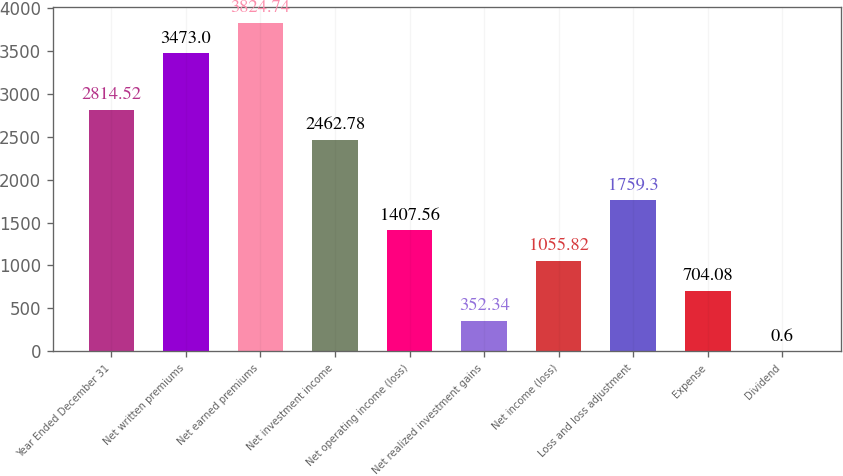Convert chart to OTSL. <chart><loc_0><loc_0><loc_500><loc_500><bar_chart><fcel>Year Ended December 31<fcel>Net written premiums<fcel>Net earned premiums<fcel>Net investment income<fcel>Net operating income (loss)<fcel>Net realized investment gains<fcel>Net income (loss)<fcel>Loss and loss adjustment<fcel>Expense<fcel>Dividend<nl><fcel>2814.52<fcel>3473<fcel>3824.74<fcel>2462.78<fcel>1407.56<fcel>352.34<fcel>1055.82<fcel>1759.3<fcel>704.08<fcel>0.6<nl></chart> 